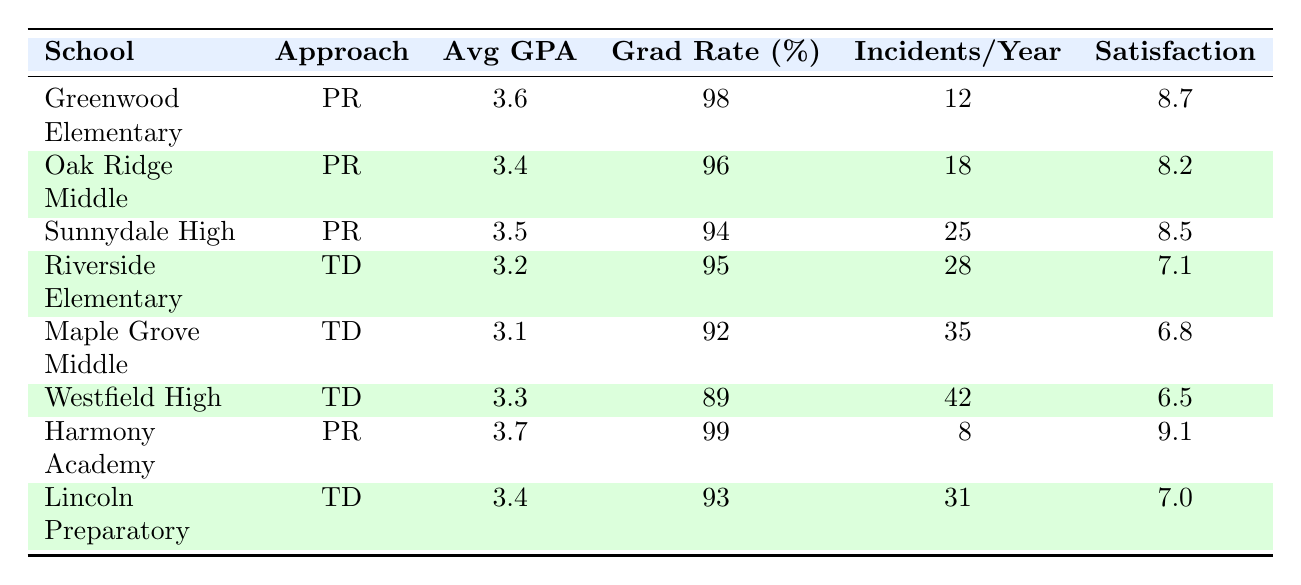What is the average GPA of schools using positive reinforcement? The schools using positive reinforcement are Greenwood Elementary (3.6), Oak Ridge Middle School (3.4), Sunnydale High (3.5), and Harmony Academy (3.7). To find the average GPA, we add these together: 3.6 + 3.4 + 3.5 + 3.7 = 14.2, then divide by 4: 14.2 / 4 = 3.55.
Answer: 3.55 Which school has the highest graduation rate? The graduation rates for the schools are as follows: Greenwood Elementary (98%), Oak Ridge Middle School (96%), Sunnydale High (94%), Riverside Elementary (95%), Maple Grove Middle (92%), Westfield High (89%), Harmony Academy (99%), and Lincoln Preparatory (93%). Harmony Academy has the highest graduation rate at 99%.
Answer: 99% Is the average behavioral incidents per year higher for traditional disciplinary schools than for positive reinforcement schools? For positive reinforcement schools, the incidents are: Greenwood Elementary (12), Oak Ridge Middle (18), Sunnydale High (25), and Harmony Academy (8), averaging to (12 + 18 + 25 + 8) / 4 = 15.75. For traditional disciplinary schools, the incidents are: Riverside Elementary (28), Maple Grove (35), Westfield High (42), and Lincoln Preparatory (31), averaging to (28 + 35 + 42 + 31) / 4 = 34. The average for traditional schools (34) is indeed higher than for positive reinforcement schools (15.75).
Answer: Yes What is the total number of behavioral incidents per year across all schools? To find the total, we need to sum all behavioral incidents: 12 + 18 + 25 + 28 + 35 + 42 + 8 + 31 = 199.
Answer: 199 Which disciplinary approach has a higher student satisfaction score, and what is the score difference? The positive reinforcement schools have scores: 8.7, 8.2, 8.5, and 9.1, averaging to (8.7 + 8.2 + 8.5 + 9.1) / 4 = 8.625. The traditional disciplinary schools have scores: 7.1, 6.8, 6.5, and 7.0, averaging to (7.1 + 6.8 + 6.5 + 7.0) / 4 = 6.85. The difference in satisfaction scores is 8.625 - 6.85 = 1.775.
Answer: Positive reinforcement; 1.775 How many schools have a graduation rate below 95%? The graduation rates below 95% are: Maple Grove Middle (92%) and Westfield High (89%). This gives us a total of 2 schools with a graduation rate below 95%.
Answer: 2 